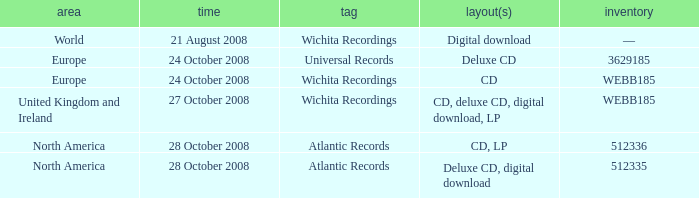Which region is associated with the catalog value of 512335? North America. Could you help me parse every detail presented in this table? {'header': ['area', 'time', 'tag', 'layout(s)', 'inventory'], 'rows': [['World', '21 August 2008', 'Wichita Recordings', 'Digital download', '—'], ['Europe', '24 October 2008', 'Universal Records', 'Deluxe CD', '3629185'], ['Europe', '24 October 2008', 'Wichita Recordings', 'CD', 'WEBB185'], ['United Kingdom and Ireland', '27 October 2008', 'Wichita Recordings', 'CD, deluxe CD, digital download, LP', 'WEBB185'], ['North America', '28 October 2008', 'Atlantic Records', 'CD, LP', '512336'], ['North America', '28 October 2008', 'Atlantic Records', 'Deluxe CD, digital download', '512335']]} 